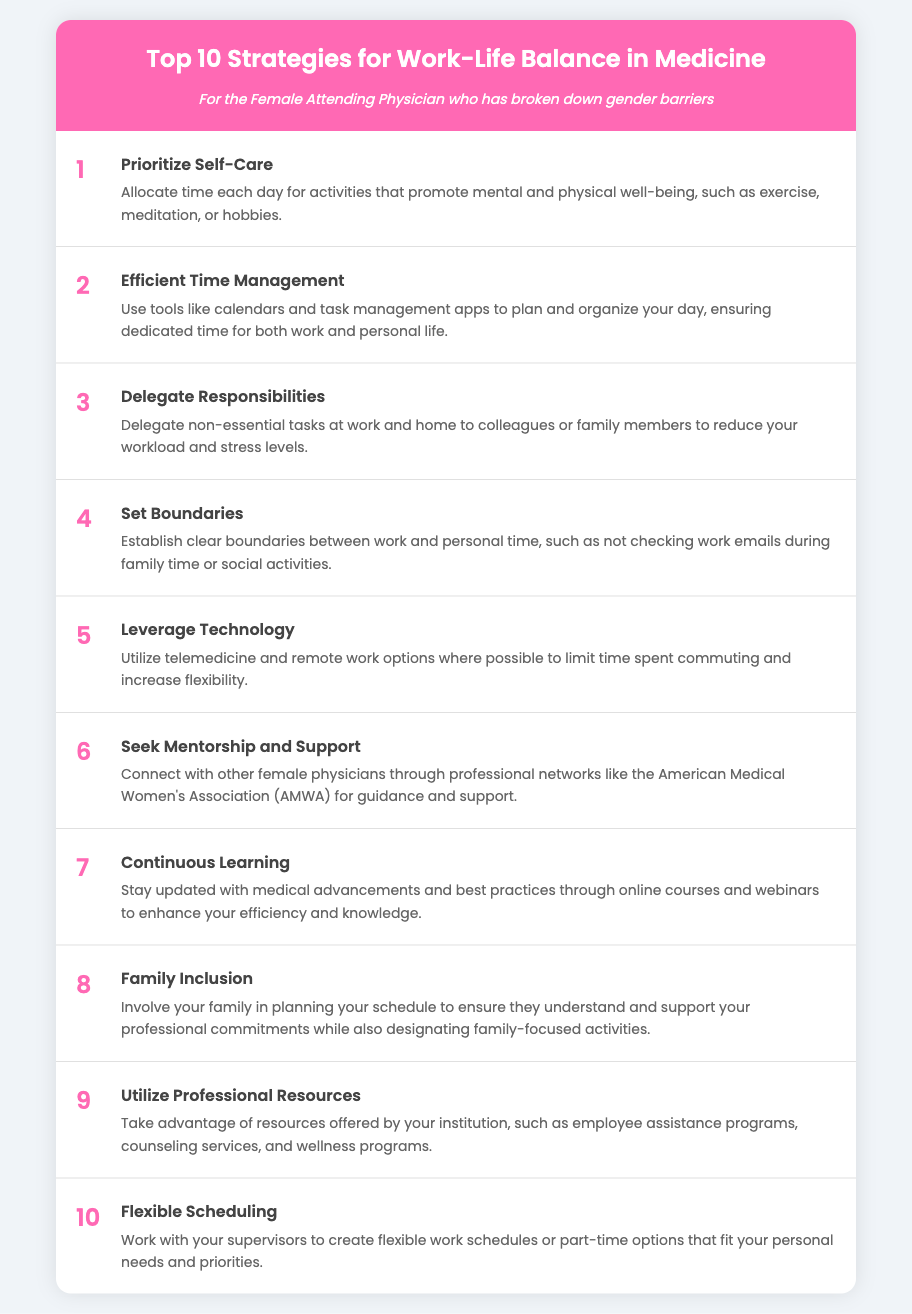What is the title of the document? The title of the document is prominently displayed in the header.
Answer: Top 10 Strategies for Work-Life Balance in Medicine What is the first strategy listed? The first strategy is stated at the beginning of the list.
Answer: Prioritize Self-Care How many strategies are included in the document? The number of strategies is specified in the title.
Answer: 10 What is the color used for the header background? The background color of the header is a specific shade mentioned in the style.
Answer: Pink Which strategy emphasizes the importance of delegating tasks? The strategy number and title signify the importance of sharing responsibilities.
Answer: Delegate Responsibilities Which professional network is mentioned for connecting with female physicians? The name of the network is included in the description of a specific strategy.
Answer: American Medical Women's Association What is the strategy that encourages involving family in scheduling? The description of the relevant strategy outlines this practice.
Answer: Family Inclusion What does the strategy regarding technology aim to achieve? The strategy suggests a way to create more adaptable work conditions.
Answer: Limit time spent commuting What is one benefit of flexible scheduling mentioned in the document? The description points out that it is related to personal needs.
Answer: Fits personal needs 